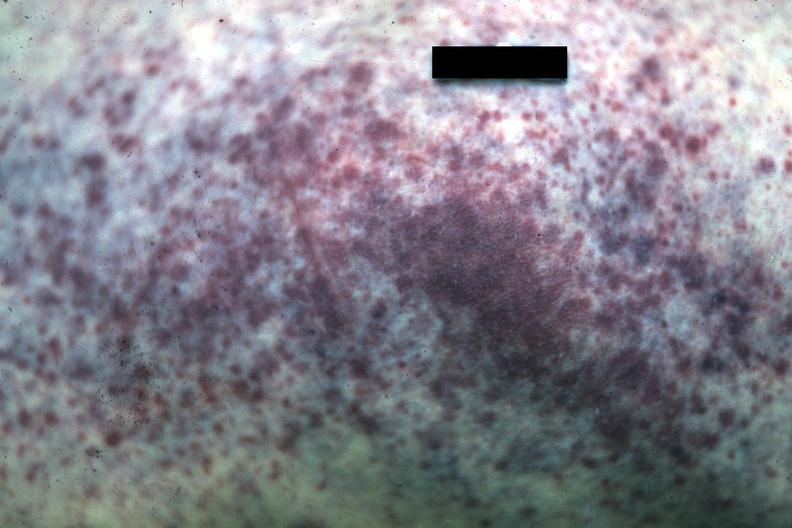what is present?
Answer the question using a single word or phrase. Petechiae 